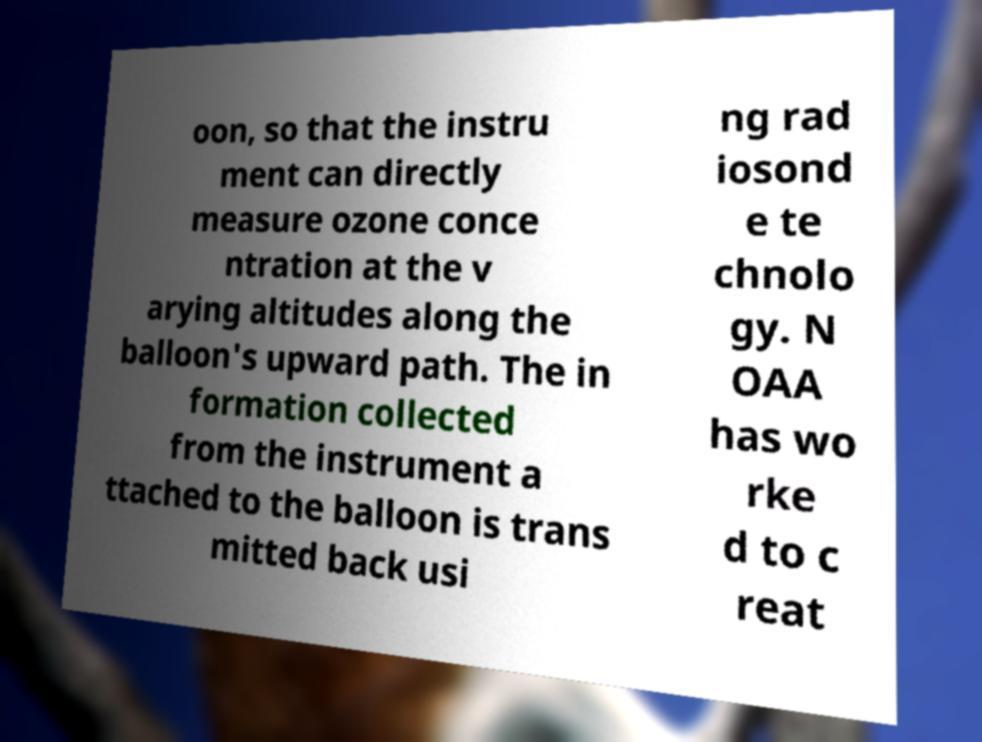I need the written content from this picture converted into text. Can you do that? oon, so that the instru ment can directly measure ozone conce ntration at the v arying altitudes along the balloon's upward path. The in formation collected from the instrument a ttached to the balloon is trans mitted back usi ng rad iosond e te chnolo gy. N OAA has wo rke d to c reat 